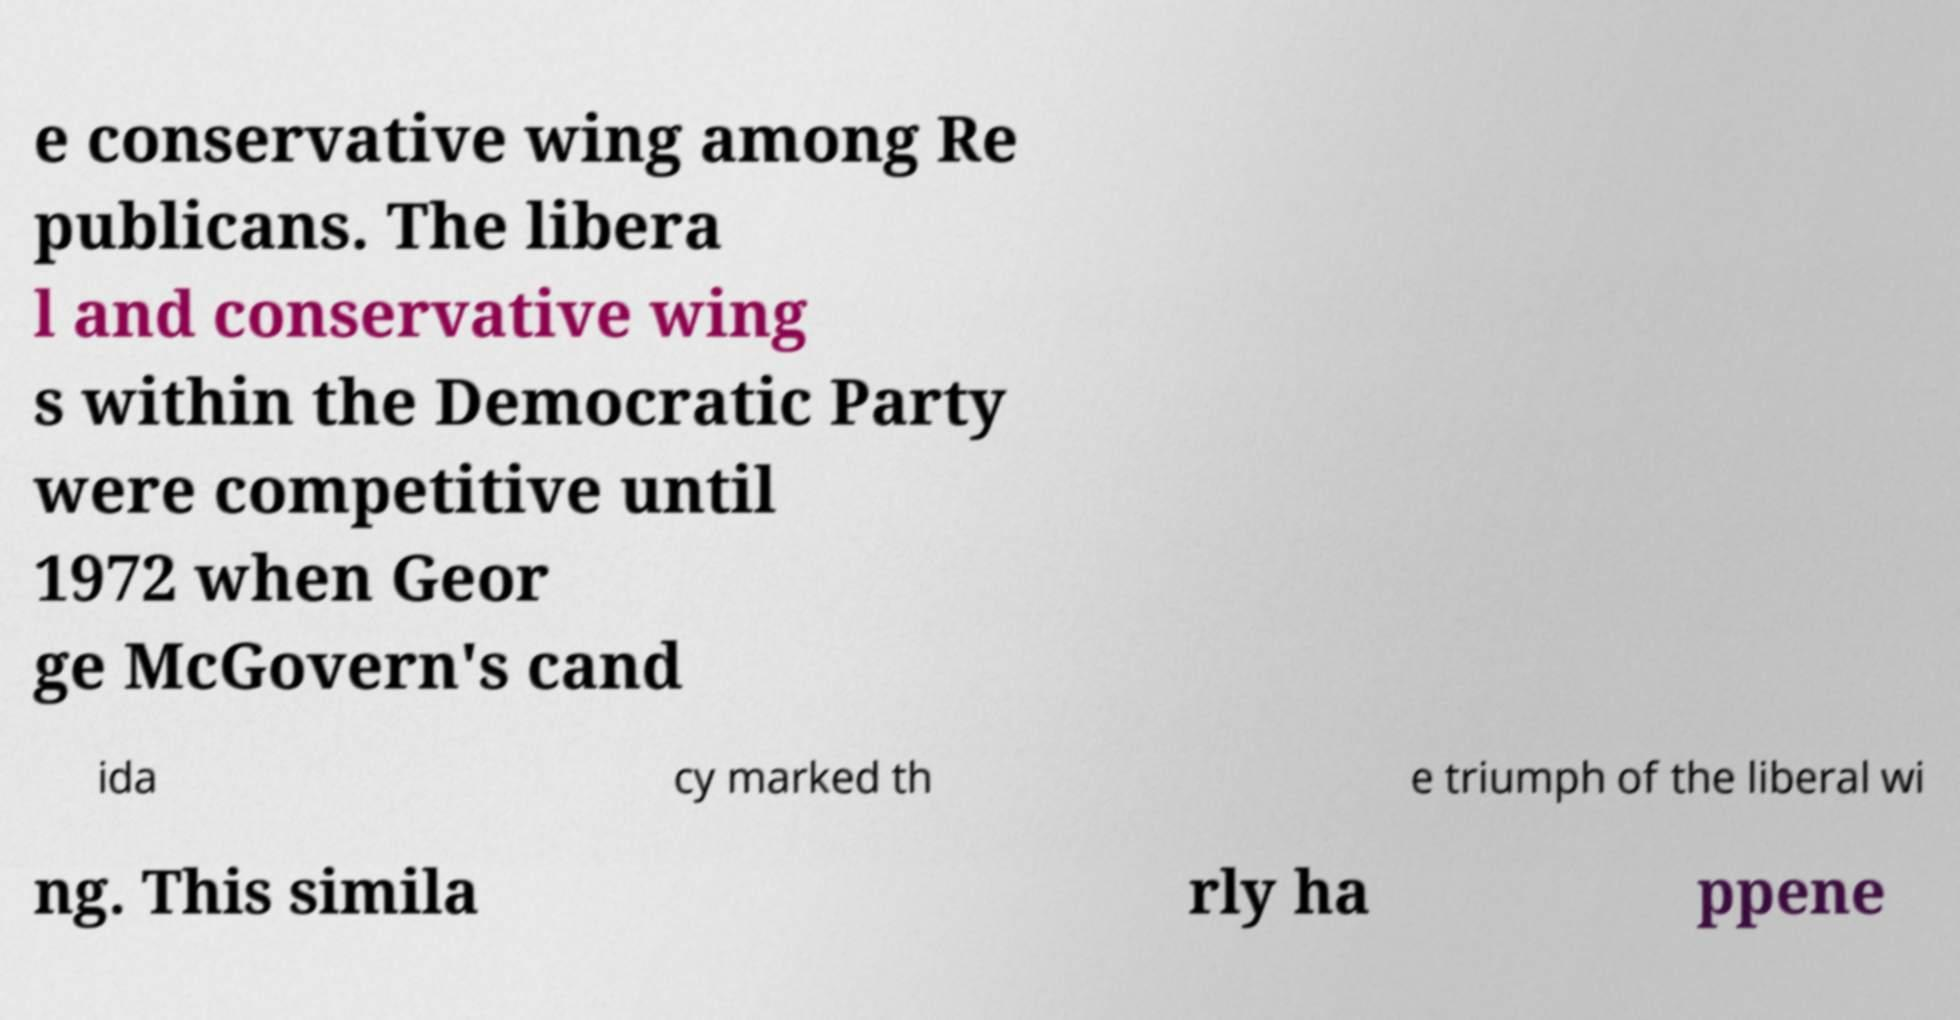For documentation purposes, I need the text within this image transcribed. Could you provide that? e conservative wing among Re publicans. The libera l and conservative wing s within the Democratic Party were competitive until 1972 when Geor ge McGovern's cand ida cy marked th e triumph of the liberal wi ng. This simila rly ha ppene 